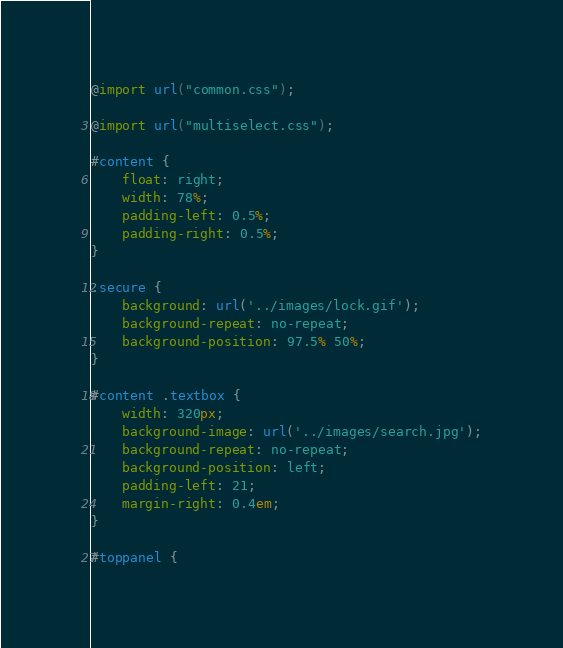<code> <loc_0><loc_0><loc_500><loc_500><_CSS_>@import url("common.css");

@import url("multiselect.css");

#content {
	float: right;
	width: 78%;
	padding-left: 0.5%;
	padding-right: 0.5%;
}

.secure {
	background: url('../images/lock.gif');
	background-repeat: no-repeat;
	background-position: 97.5% 50%;
}

#content .textbox {
	width: 320px;
	background-image: url('../images/search.jpg');
	background-repeat: no-repeat;
	background-position: left;
	padding-left: 21;
	margin-right: 0.4em;
}

#toppanel {</code> 